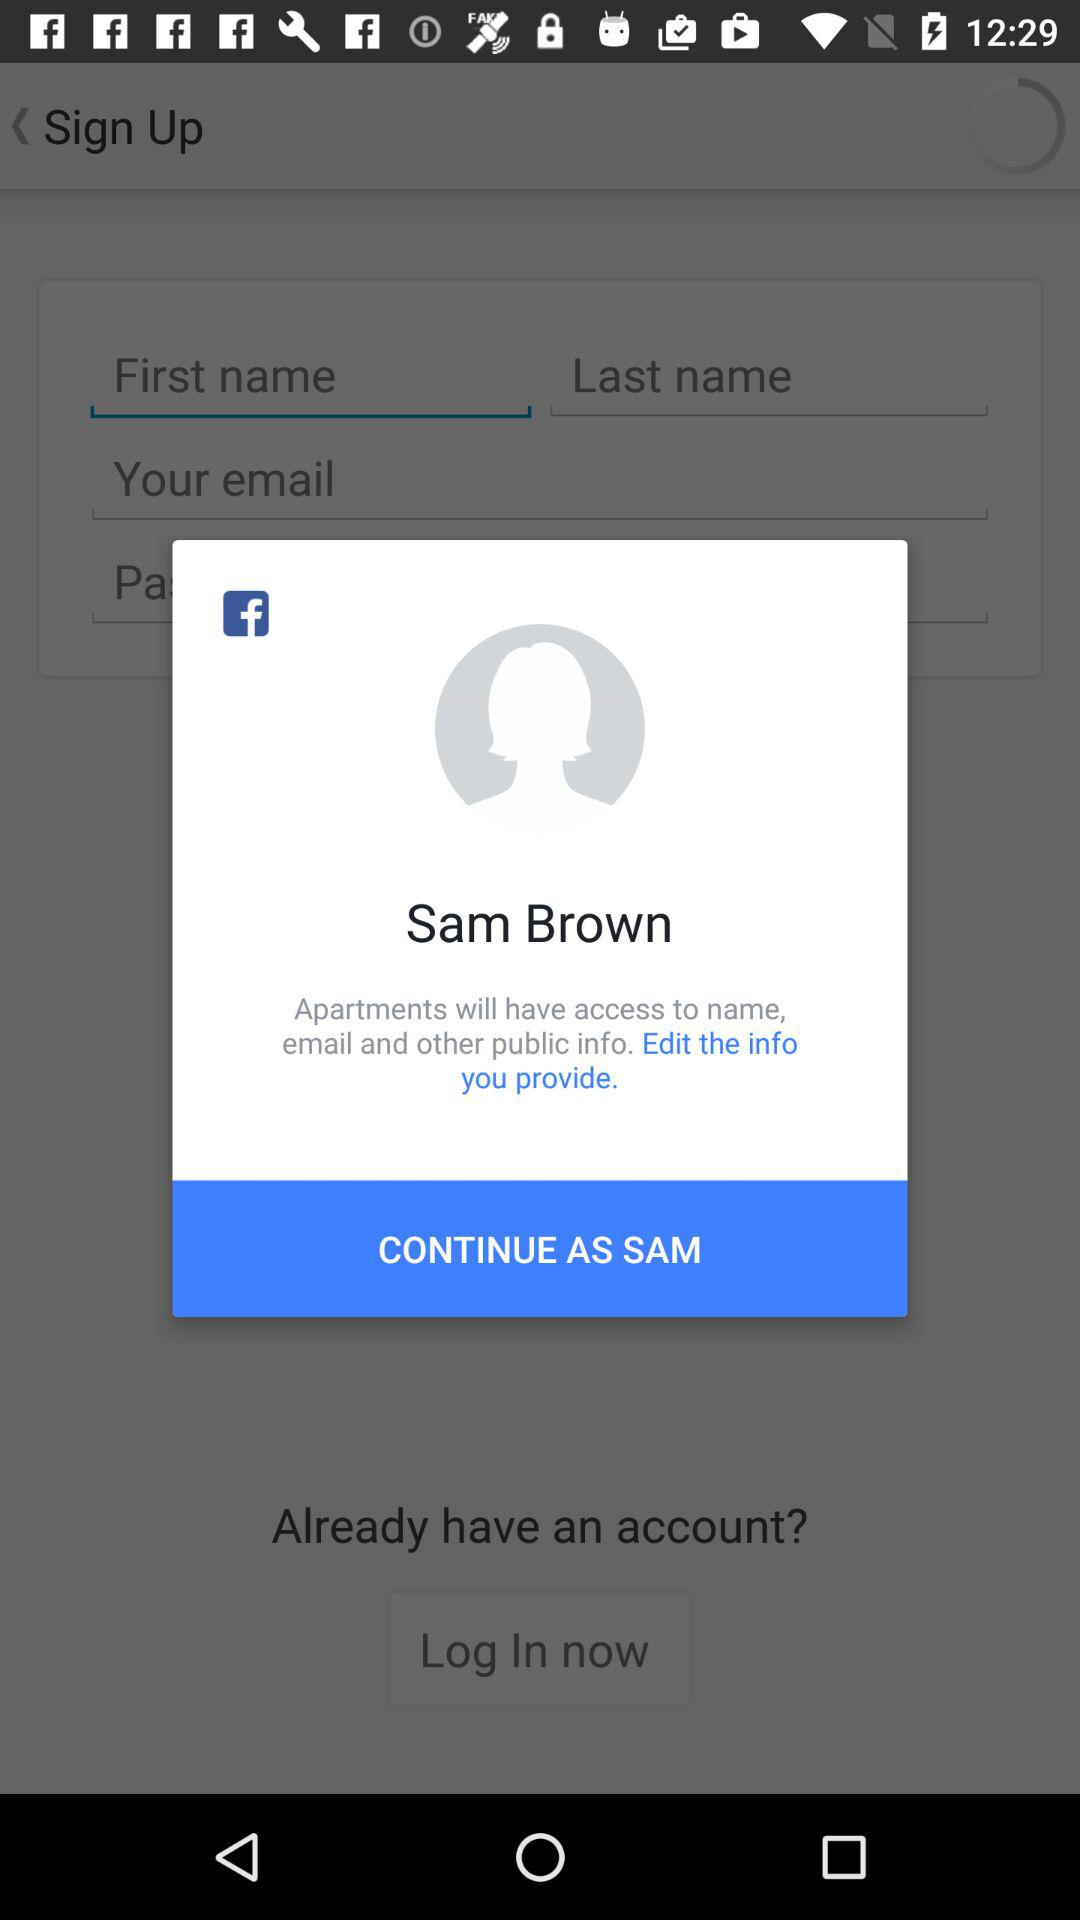What's the name of the user by which application can be continued? The name of the user is Sam Brown. 